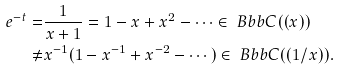Convert formula to latex. <formula><loc_0><loc_0><loc_500><loc_500>e ^ { - t } = & \frac { 1 } { x + 1 } = 1 - x + x ^ { 2 } - \cdots \in { \ B b b C } ( ( x ) ) \\ \not = & x ^ { - 1 } ( 1 - x ^ { - 1 } + x ^ { - 2 } - \cdots ) \in { \ B b b C } ( ( 1 / x ) ) .</formula> 